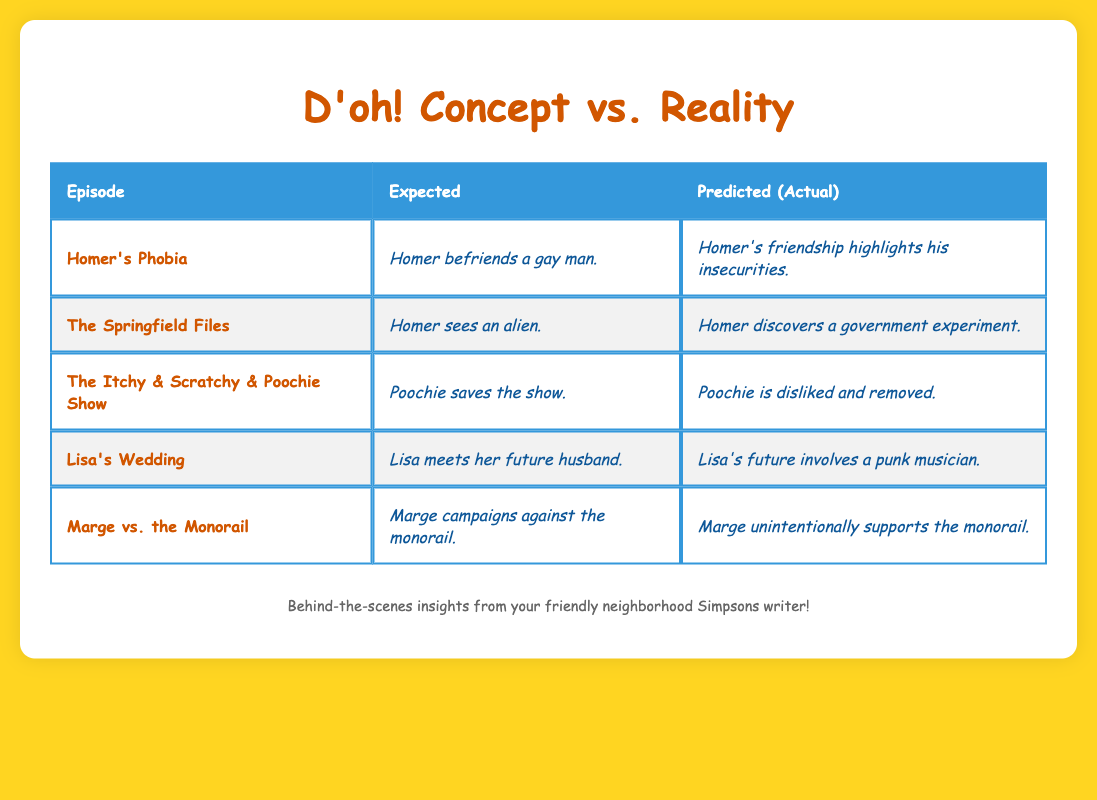What was the expected outcome for the episode "The Itchy & Scratchy & Poochie Show"? The table lists the expected outcome as "Poochie saves the show." under the "expected" column for that episode.
Answer: Poochie saves the show Which episode involved Marge campaigning against a new project? Referring to the "initial_concepts" data, "Marge vs. the Monorail" has the initial concept of "Marge campaigns against a new monorail system in Springfield."
Answer: Marge vs. the Monorail Did the predicted outcome for "Homer's Phobia" align with the expected outcome? The expected outcome is "Homer befriends a gay man," while the predicted outcome is "Homer's friendship highlights his insecurities." They are different, so the alignment is not present.
Answer: No Which final change resulted in a character being written off after fan backlash? In the final changes, it states "Poochie is written off after fans dislike him," which directly answers the question regarding character removal.
Answer: Poochie What happens in the final version of Lisa's future compared to her initial concept? The expected outcome was "Lisa meets her future husband," but the final change shows that "Lisa's future involves a punk musician," indicating a shift in character direction.
Answer: Shift to a punk musician If we compare the expected and predicted outcomes of "The Springfield Files," how many of them were different? Looking at the table, the expected outcome is "Homer sees an alien" and the predicted outcome is "Homer discovers a government experiment." They are different, which accounts for one instance of divergence.
Answer: One Was there any episode where the final change was significantly different from the initial concept? Analyzing the data, "Lisa's Wedding" saw a significant change from the initial concept of meeting her husband to seeing a punk musician, which reflects a considerable deviation.
Answer: Yes What were the predictions for the episode "Marge vs. the Monorail"? The table indicates that the predicted outcome for "Marge vs. the Monorail" is "Marge unintentionally supports the monorail."
Answer: Marge unintentionally supports the monorail 